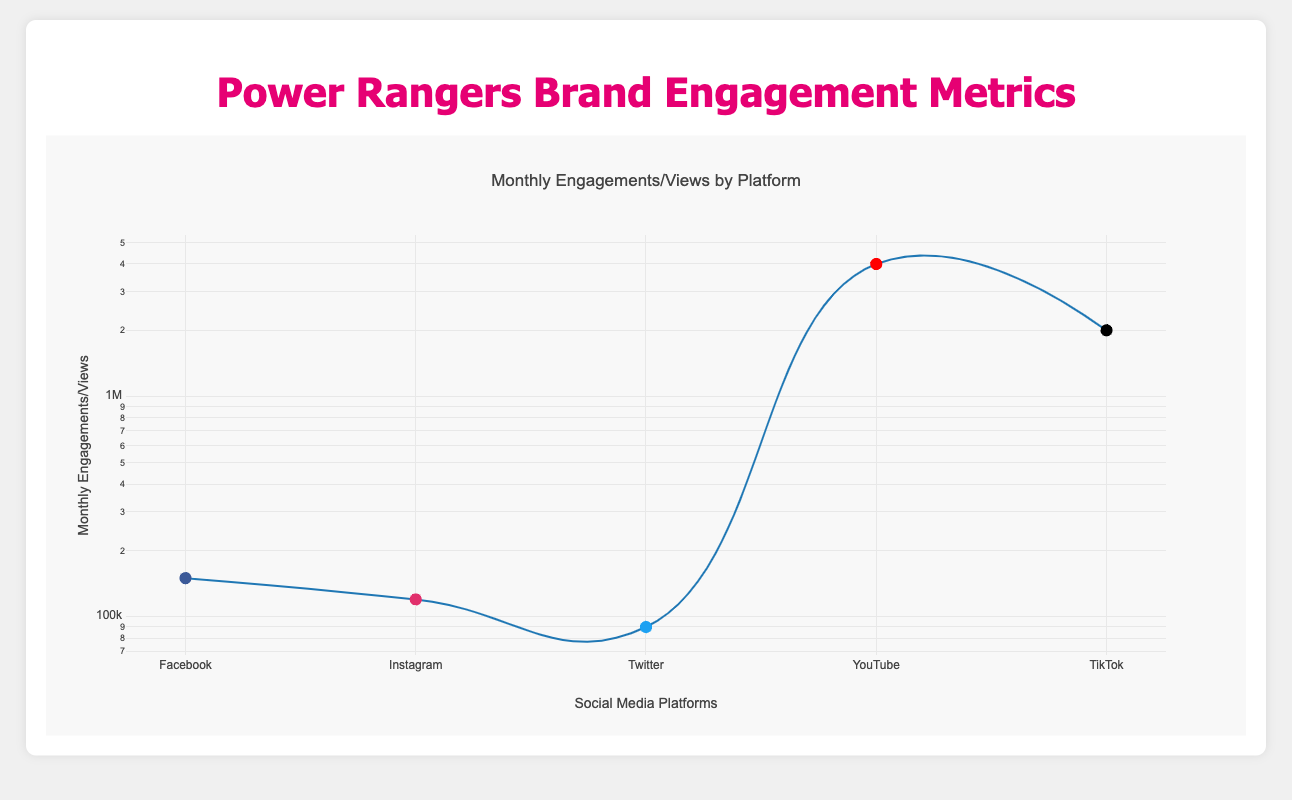What is the total number of likes on Facebook? The table shows that the total number of likes on Facebook is explicitly listed as 2,500,000.
Answer: 2,500,000 Which platform has the highest monthly engagements? By comparing the monthly engagements across platforms, Facebook has 150,000, Instagram has 120,000, Twitter has 90,000, YouTube has 4,000,000 views (not engagements directly), and TikTok has 2,000,000 views. Therefore, YouTube has the highest engagement based on views and other platforms' direct engagements.
Answer: YouTube Is the total likes on TikTok greater than the total shares on Facebook? The total likes on TikTok are 300,000, while the total shares on Facebook are 80,000. Since 300,000 is greater than 80,000, the statement is true.
Answer: Yes What is the combined total of monthly engagements for Facebook and Instagram? The monthly engagements for Facebook are 150,000 and for Instagram are 120,000. Adding these two figures together gives 150,000 + 120,000 = 270,000.
Answer: 270,000 Which platform has the least amount of comments? The table shows the following comments: Facebook has 20,000, Instagram has 15,000, Twitter has no comments listed, YouTube has 2,500, and TikTok has 50,000. Since Twitter does not have a value listed, it has the least number of comments.
Answer: Twitter What is the average monthly engagements across all platforms that provide this metric? The platforms that provide monthly engagements are Facebook (150,000), Instagram (120,000), Twitter (90,000), YouTube (4,000,000 views considered as engagements), and TikTok (2,000,000 views). Summing these values gives 150,000 + 120,000 + 90,000 + 4,000,000 + 2,000,000 = 6,360,000. There are 5 platforms, so the average is 6,360,000 / 5 = 1,272,000.
Answer: 1,272,000 Does TikTok have more total likes than Twitter? TikTok has a total of 300,000 likes, while Twitter does not specifically list total likes but has 30,000 likes mentioned. Thus, TikTok indeed has more total likes than Twitter.
Answer: Yes What is the difference in total likes between Facebook and Instagram? Facebook has 2,500,000 likes and Instagram has 1,800,000 likes. To find the difference, subtract the total likes of Instagram from Facebook: 2,500,000 - 1,800,000 = 700,000.
Answer: 700,000 Which platform has the highest total followers? The number of followers is listed for Twitter (500,000) and TikTok (600,000). Since TikTok has the value of 600,000 which is greater than Twitter's 500,000, TikTok has the highest total followers.
Answer: TikTok 